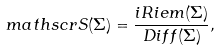<formula> <loc_0><loc_0><loc_500><loc_500>\ m a t h s c r { S } ( \Sigma ) = \frac { i R i e m ( \Sigma ) } { D i f f ( \Sigma ) } ,</formula> 